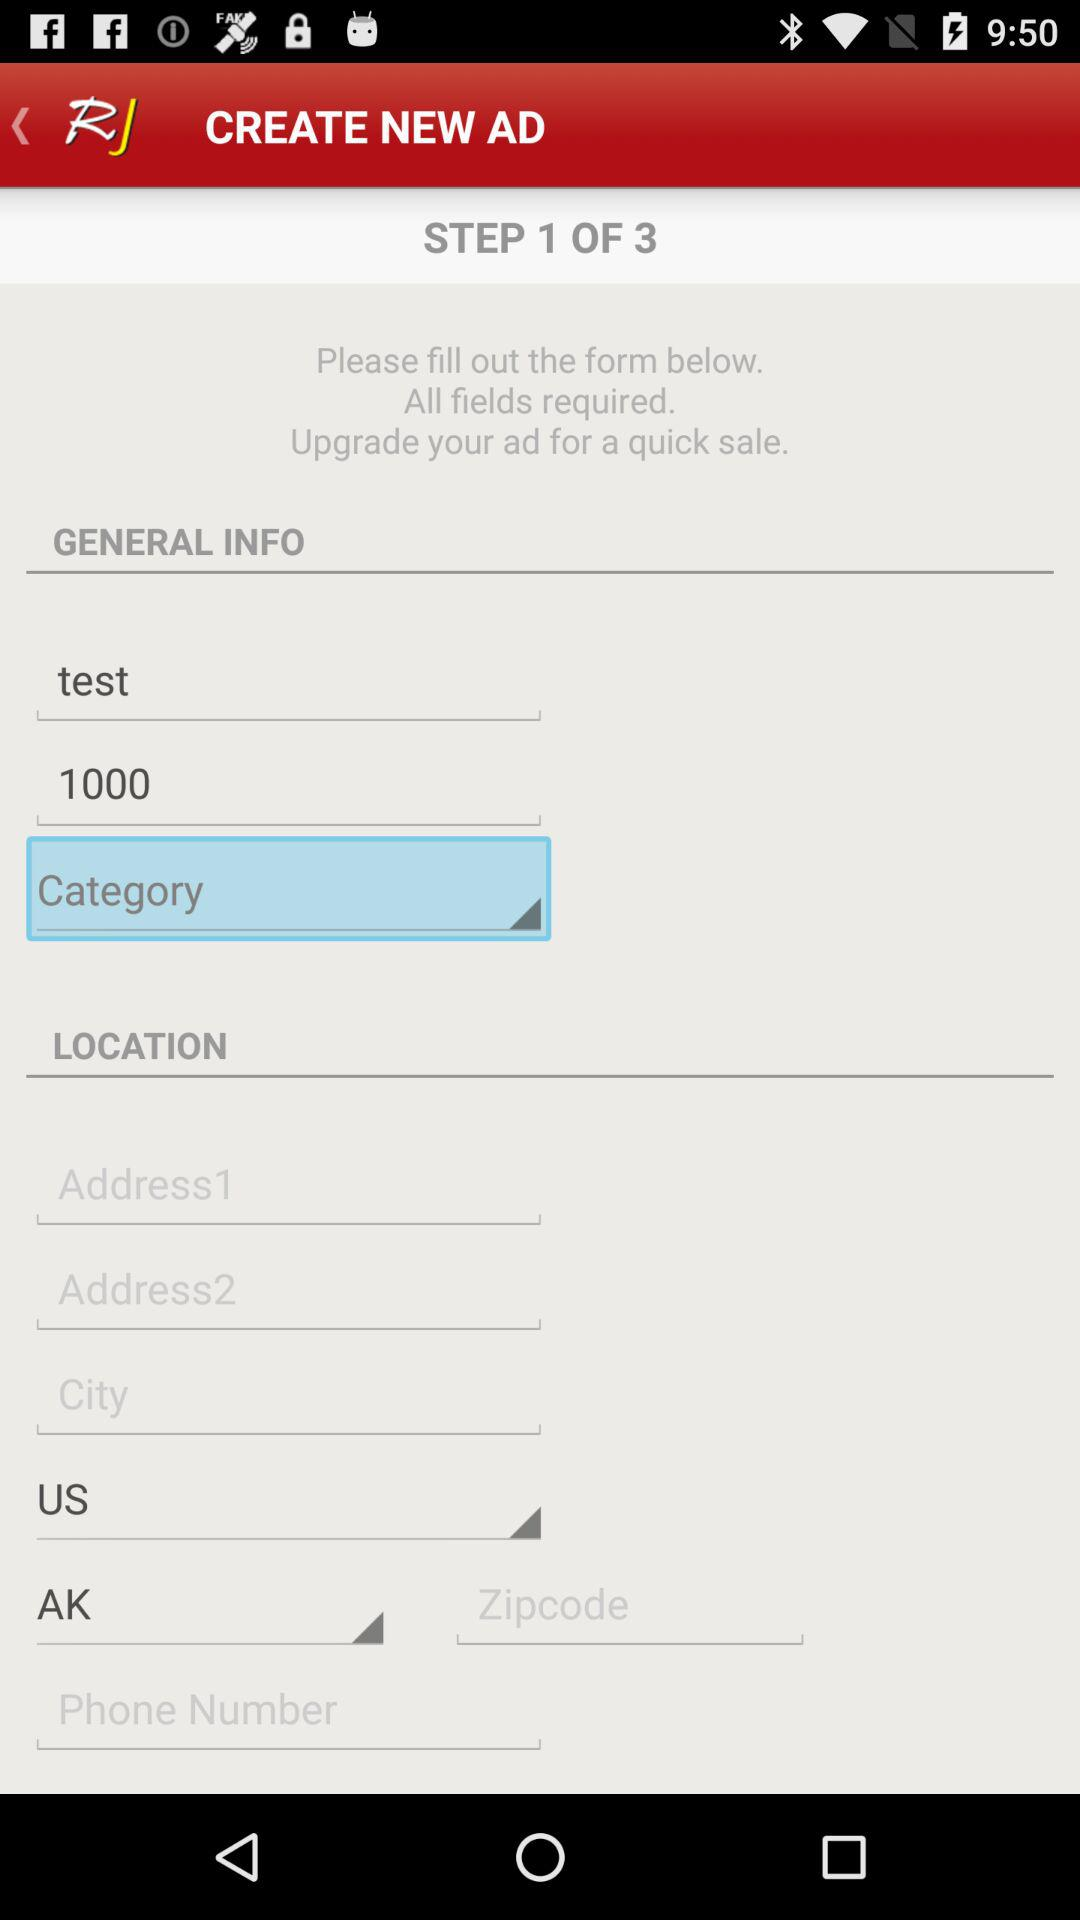Which country is selected? The selected country is the United States. 